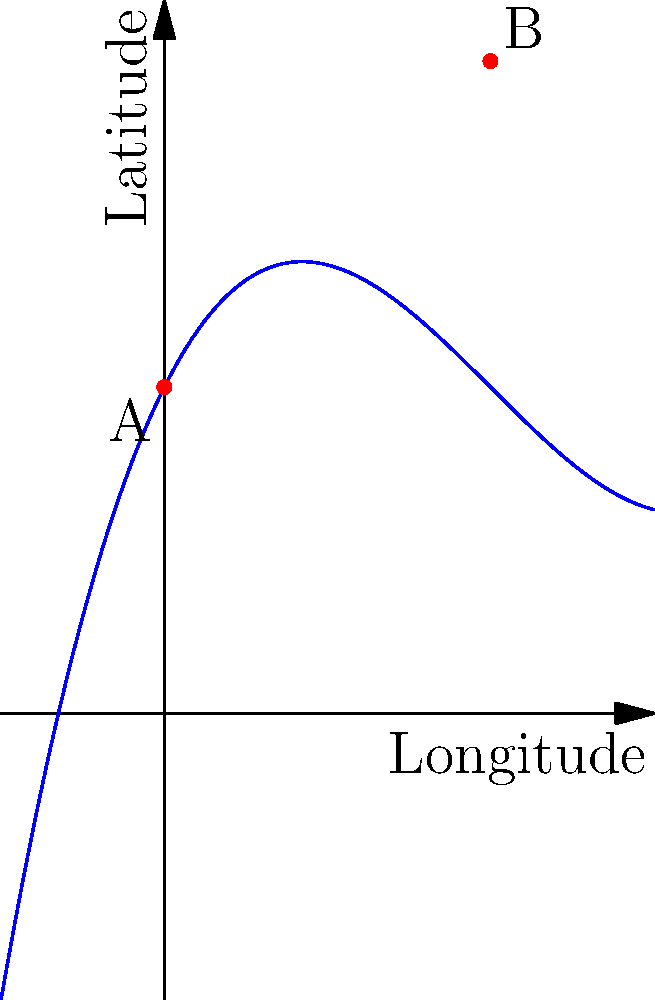As a traditional cartographer, you're tasked with illustrating a historical trade route between two ports (A and B) on a stylized map. The route is best represented by a cubic polynomial function. Given that port A is located at coordinates (0°, 10°) and port B is at (10°, 20°), which of the following polynomials most accurately represents this trade route?

a) $f(x) = 0.01x^3 - 0.3x^2 + 2x + 10$
b) $f(x) = 0.02x^3 - 0.4x^2 + 3x + 10$
c) $f(x) = 0.03x^3 - 0.2x^2 + x + 10$
d) $f(x) = 0.01x^3 - 0.2x^2 + 2x + 15$ To determine the correct polynomial, we need to consider the following steps:

1. The polynomial should pass through both points A(0, 10) and B(10, 20).

2. Let's check each option:

   a) $f(x) = 0.01x^3 - 0.3x^2 + 2x + 10$
      At x = 0: $f(0) = 10$ (passes through A)
      At x = 10: $f(10) = 0.01(1000) - 0.3(100) + 2(10) + 10 = 10 - 30 + 20 + 10 = 20$ (passes through B)

   b) $f(x) = 0.02x^3 - 0.4x^2 + 3x + 10$
      At x = 0: $f(0) = 10$ (passes through A)
      At x = 10: $f(10) = 0.02(1000) - 0.4(100) + 3(10) + 10 = 20 - 40 + 30 + 10 = 20$ (passes through B)

   c) $f(x) = 0.03x^3 - 0.2x^2 + x + 10$
      At x = 0: $f(0) = 10$ (passes through A)
      At x = 10: $f(10) = 0.03(1000) - 0.2(100) + 10 + 10 = 30 - 20 + 20 = 30$ (does not pass through B)

   d) $f(x) = 0.01x^3 - 0.2x^2 + 2x + 15$
      At x = 0: $f(0) = 15$ (does not pass through A)

3. Options a) and b) both pass through points A and B. However, looking at the graph provided, we can see that the curve matches the shape of option a).

4. The curve in the graph starts at (0, 10), has a slight dip, and then rises to (10, 20), which is consistent with the behavior of $f(x) = 0.01x^3 - 0.3x^2 + 2x + 10$.

Therefore, the polynomial that most accurately represents this trade route is option a).
Answer: a) $f(x) = 0.01x^3 - 0.3x^2 + 2x + 10$ 